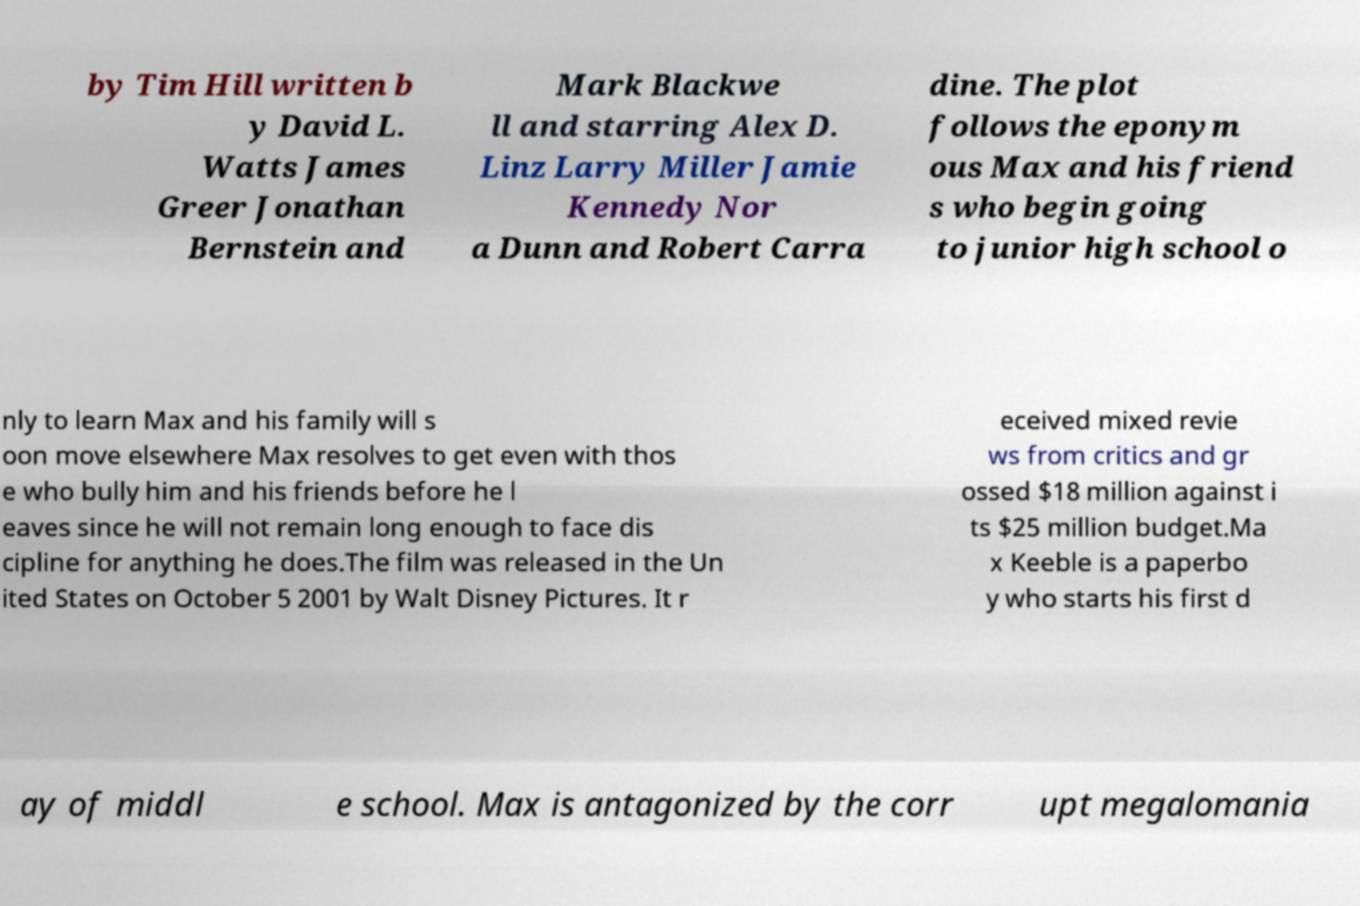Could you assist in decoding the text presented in this image and type it out clearly? by Tim Hill written b y David L. Watts James Greer Jonathan Bernstein and Mark Blackwe ll and starring Alex D. Linz Larry Miller Jamie Kennedy Nor a Dunn and Robert Carra dine. The plot follows the eponym ous Max and his friend s who begin going to junior high school o nly to learn Max and his family will s oon move elsewhere Max resolves to get even with thos e who bully him and his friends before he l eaves since he will not remain long enough to face dis cipline for anything he does.The film was released in the Un ited States on October 5 2001 by Walt Disney Pictures. It r eceived mixed revie ws from critics and gr ossed $18 million against i ts $25 million budget.Ma x Keeble is a paperbo y who starts his first d ay of middl e school. Max is antagonized by the corr upt megalomania 